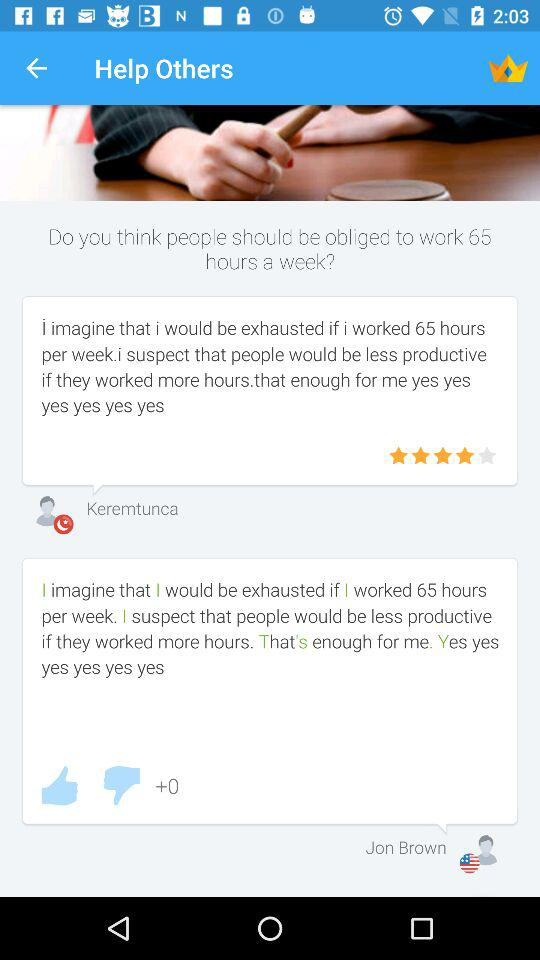How many likes are there? There are 0 likes. 